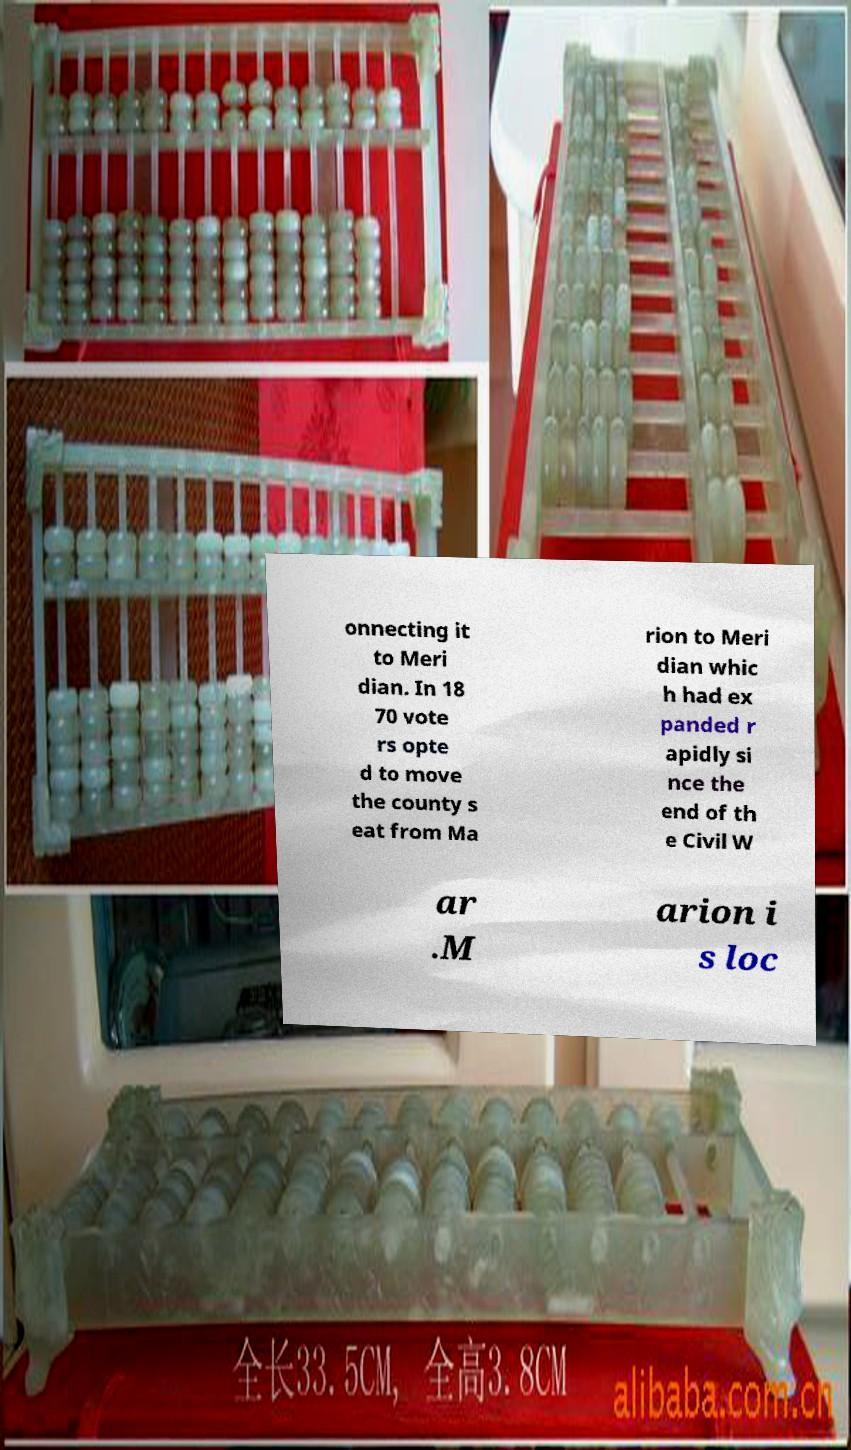I need the written content from this picture converted into text. Can you do that? onnecting it to Meri dian. In 18 70 vote rs opte d to move the county s eat from Ma rion to Meri dian whic h had ex panded r apidly si nce the end of th e Civil W ar .M arion i s loc 